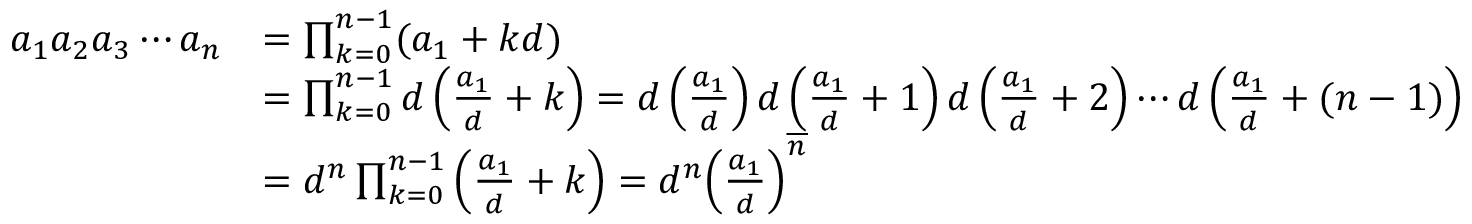Convert formula to latex. <formula><loc_0><loc_0><loc_500><loc_500>{ \begin{array} { r l } { a _ { 1 } a _ { 2 } a _ { 3 } \cdots a _ { n } } & { = \prod _ { k = 0 } ^ { n - 1 } ( a _ { 1 } + k d ) } \\ & { = \prod _ { k = 0 } ^ { n - 1 } d \left ( { \frac { a _ { 1 } } { d } } + k \right ) = d \left ( { \frac { a _ { 1 } } { d } } \right ) d \left ( { \frac { a _ { 1 } } { d } } + 1 \right ) d \left ( { \frac { a _ { 1 } } { d } } + 2 \right ) \cdots d \left ( { \frac { a _ { 1 } } { d } } + ( n - 1 ) \right ) } \\ & { = d ^ { n } \prod _ { k = 0 } ^ { n - 1 } \left ( { \frac { a _ { 1 } } { d } } + k \right ) = d ^ { n } { \left ( { \frac { a _ { 1 } } { d } } \right ) } ^ { \overline { n } } } \end{array} }</formula> 